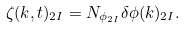<formula> <loc_0><loc_0><loc_500><loc_500>\zeta ( k , t ) _ { 2 I } = N _ { \phi _ { 2 I } } \delta \phi ( k ) _ { 2 I } .</formula> 